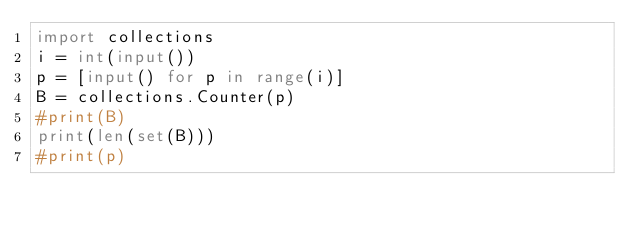<code> <loc_0><loc_0><loc_500><loc_500><_Python_>import collections
i = int(input())
p = [input() for p in range(i)]
B = collections.Counter(p)
#print(B)
print(len(set(B)))
#print(p)</code> 